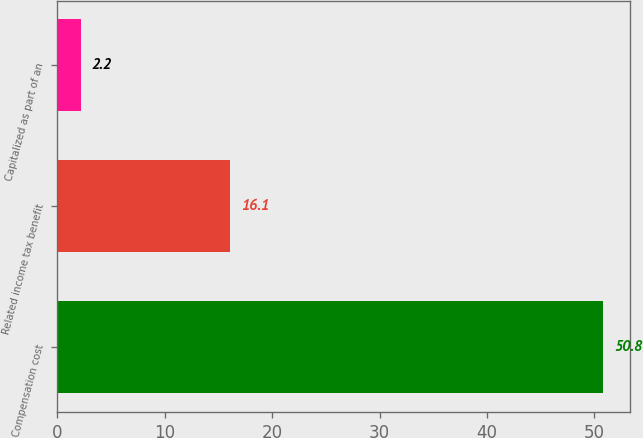Convert chart. <chart><loc_0><loc_0><loc_500><loc_500><bar_chart><fcel>Compensation cost<fcel>Related income tax benefit<fcel>Capitalized as part of an<nl><fcel>50.8<fcel>16.1<fcel>2.2<nl></chart> 